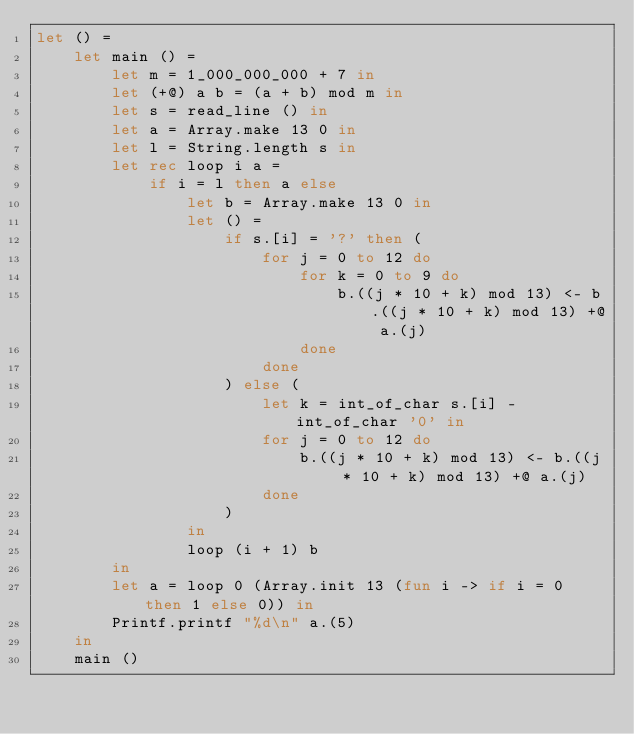<code> <loc_0><loc_0><loc_500><loc_500><_OCaml_>let () =
    let main () =
        let m = 1_000_000_000 + 7 in
        let (+@) a b = (a + b) mod m in
        let s = read_line () in
        let a = Array.make 13 0 in
        let l = String.length s in
        let rec loop i a =
            if i = l then a else
                let b = Array.make 13 0 in
                let () =
                    if s.[i] = '?' then (
                        for j = 0 to 12 do
                            for k = 0 to 9 do
                                b.((j * 10 + k) mod 13) <- b.((j * 10 + k) mod 13) +@ a.(j)
                            done
                        done
                    ) else (
                        let k = int_of_char s.[i] - int_of_char '0' in
                        for j = 0 to 12 do
                            b.((j * 10 + k) mod 13) <- b.((j * 10 + k) mod 13) +@ a.(j)
                        done
                    )
                in
                loop (i + 1) b
        in
        let a = loop 0 (Array.init 13 (fun i -> if i = 0 then 1 else 0)) in
        Printf.printf "%d\n" a.(5)
    in
    main ()</code> 